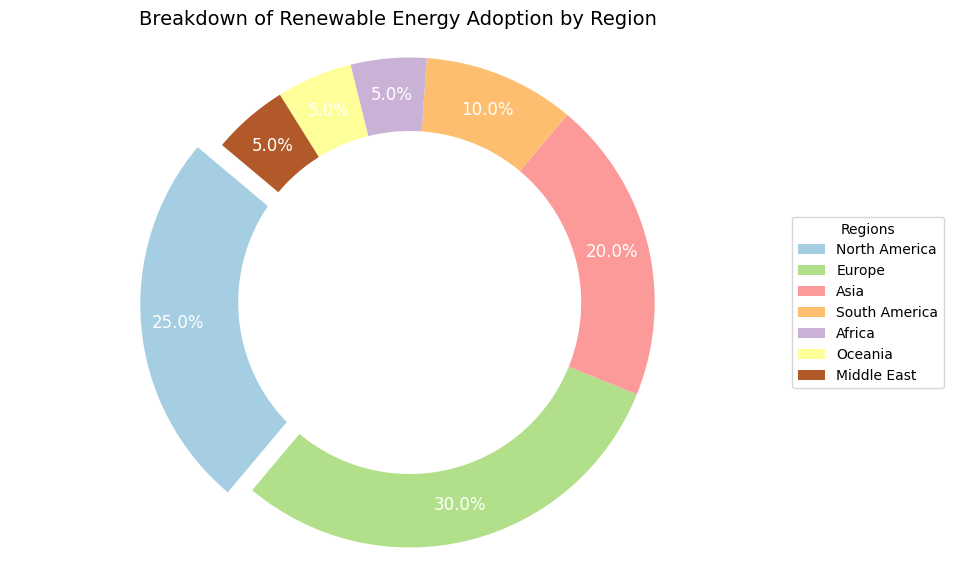What percentage of renewable energy adoption is attributed to North America? The pie chart shows that North America takes a 25% slice of the renewable energy adoption. By looking at the chart, we can see the label 'North America' paired with '25%' on its segment.
Answer: 25% How does Europe's renewable energy adoption compare to Asia's? From the pie chart, Europe's slice is labeled 30% while Asia's is labeled 20%. Europe has a larger percentage of renewable energy adoption compared to Asia by 10%.
Answer: Europe is 10% higher than Asia Which region has the smallest percentage of renewable energy adoption, and what is that percentage? Inspection of the pie chart shows that Africa, Oceania, and the Middle East each have the smallest percentages, all being 5%.
Answer: Africa, Oceania, and the Middle East all at 5% What total percentage of renewable energy adoption is contributed by South America, Africa, Oceania, and the Middle East combined? Adding the percentages from these regions: South America (10%) + Africa (5%) + Oceania (5%) + Middle East (5%) sums up to 25%.
Answer: 25% If North America and Europe were combined into a single region, what percentage would they collectively represent? Adding North America's 25% to Europe's 30% results in a collective percentage of 55%.
Answer: 55% Describe the visual difference in the sizes between the pie chart segments of Europe and Asia. The segment for Europe is larger than Asia's segment. Since Europe has 30% and Asia has 20%, Europe's slice visually occupies more space on the chart.
Answer: Europe's segment is larger than Asia's segment Which region's segment is slightly exploded outward? The segment for North America is slightly exploded outward as indicated by the visual gap from the rest of the pie chart.
Answer: North America What is the total percentage of renewable energy adoption by regions other than Europe and North America? Subtracting the combined Europe and North America percentage (55%) from 100% leaves 45%. This is the total of the remaining regions: Asia, South America, Africa, Oceania, and the Middle East.
Answer: 45% Which regions have visually similar sized segments in the pie chart? Africa, Oceania, and the Middle East all have visually similar sized segments as they each represent 5% of the adoption.
Answer: Africa, Oceania, and the Middle East 